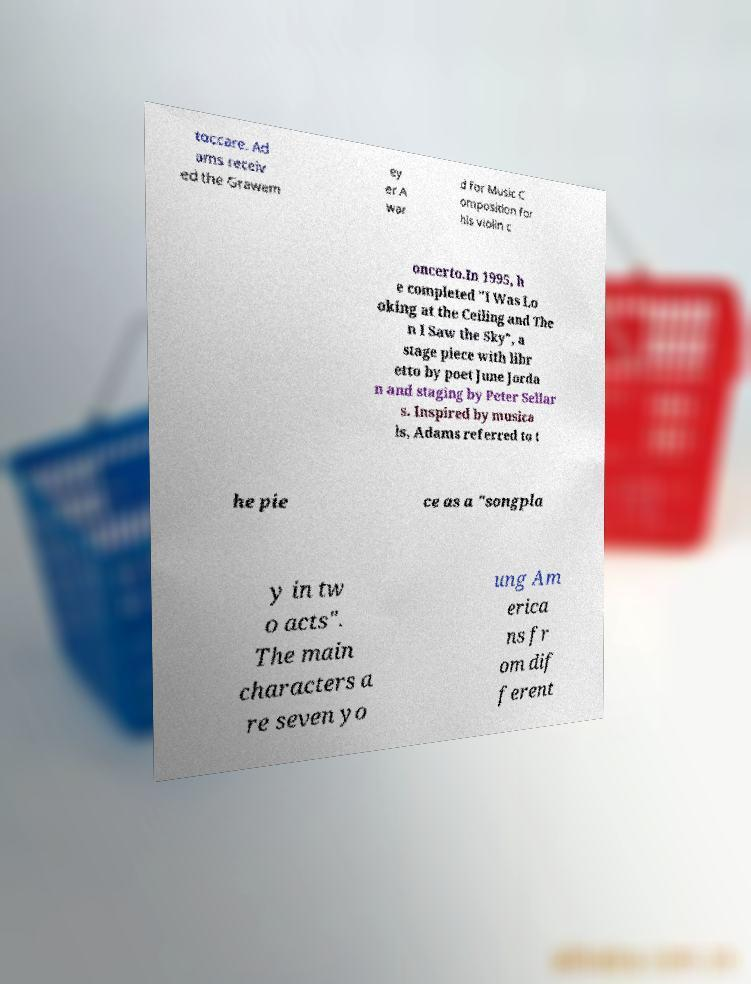Can you read and provide the text displayed in the image?This photo seems to have some interesting text. Can you extract and type it out for me? toccare. Ad ams receiv ed the Grawem ey er A war d for Music C omposition for his violin c oncerto.In 1995, h e completed "I Was Lo oking at the Ceiling and The n I Saw the Sky", a stage piece with libr etto by poet June Jorda n and staging by Peter Sellar s. Inspired by musica ls, Adams referred to t he pie ce as a "songpla y in tw o acts". The main characters a re seven yo ung Am erica ns fr om dif ferent 